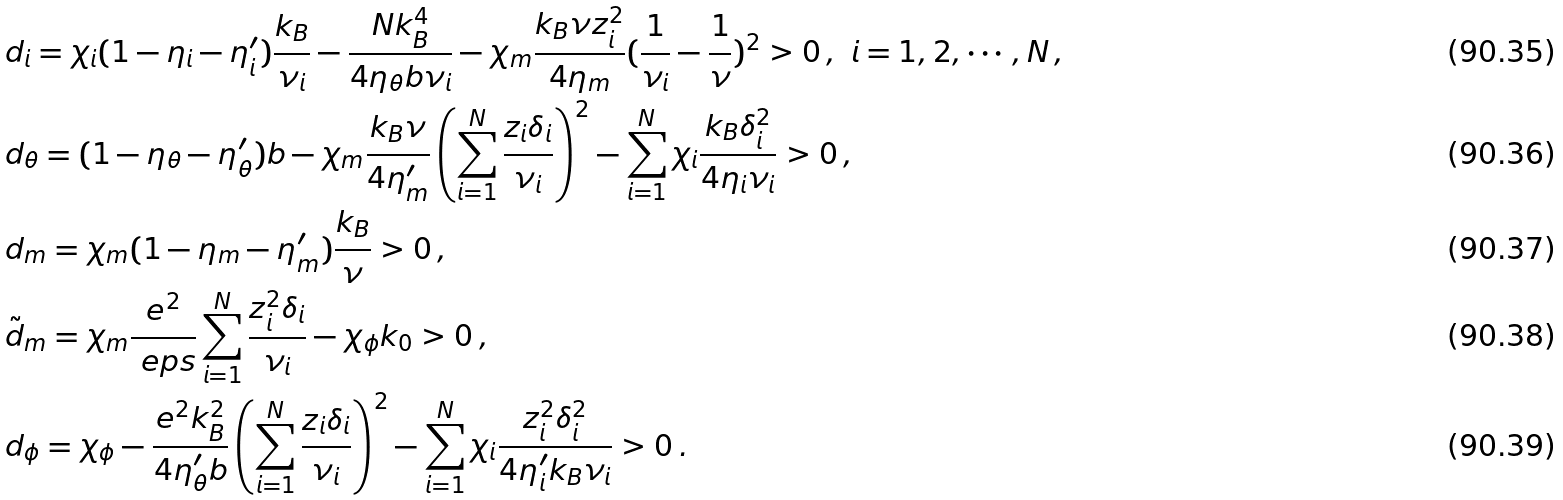<formula> <loc_0><loc_0><loc_500><loc_500>& d _ { i } = \chi _ { i } ( 1 - \eta _ { i } - \eta _ { i } ^ { \prime } ) \frac { k _ { B } } { \nu _ { i } } - \frac { N k _ { B } ^ { 4 } } { 4 \eta _ { \theta } b \nu _ { i } } - \chi _ { m } \frac { k _ { B } \nu z _ { i } ^ { 2 } } { 4 \eta _ { m } } ( \frac { 1 } { \nu _ { i } } - \frac { 1 } { \nu } ) ^ { 2 } > 0 \, , \ i = 1 , 2 , \cdots , N \, , \\ & d _ { \theta } = ( 1 - \eta _ { \theta } - \eta _ { \theta } ^ { \prime } ) b - \chi _ { m } \frac { k _ { B } \nu } { 4 \eta _ { m } ^ { \prime } } \left ( \sum _ { i = 1 } ^ { N } \frac { z _ { i } \delta _ { i } } { \nu _ { i } } \right ) ^ { 2 } - \sum _ { i = 1 } ^ { N } \chi _ { i } \frac { k _ { B } \delta _ { i } ^ { 2 } } { 4 \eta _ { i } \nu _ { i } } > 0 \, , \\ & d _ { m } = \chi _ { m } ( 1 - \eta _ { m } - \eta _ { m } ^ { \prime } ) \frac { k _ { B } } { \nu } > 0 \, , \\ & \tilde { d } _ { m } = \chi _ { m } \frac { e ^ { 2 } } { \ e p s } \sum _ { i = 1 } ^ { N } \frac { z _ { i } ^ { 2 } \delta _ { i } } { \nu _ { i } } - \chi _ { \phi } k _ { 0 } > 0 \, , \\ & d _ { \phi } = \chi _ { \phi } - \frac { e ^ { 2 } k _ { B } ^ { 2 } } { 4 \eta _ { \theta } ^ { \prime } b } \left ( \sum _ { i = 1 } ^ { N } \frac { z _ { i } \delta _ { i } } { \nu _ { i } } \right ) ^ { 2 } - \sum _ { i = 1 } ^ { N } \chi _ { i } \frac { z _ { i } ^ { 2 } \delta _ { i } ^ { 2 } } { 4 \eta _ { i } ^ { \prime } k _ { B } \nu _ { i } } > 0 \, .</formula> 